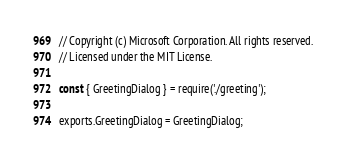Convert code to text. <code><loc_0><loc_0><loc_500><loc_500><_JavaScript_>// Copyright (c) Microsoft Corporation. All rights reserved.
// Licensed under the MIT License.

const { GreetingDialog } = require('./greeting');

exports.GreetingDialog = GreetingDialog;</code> 